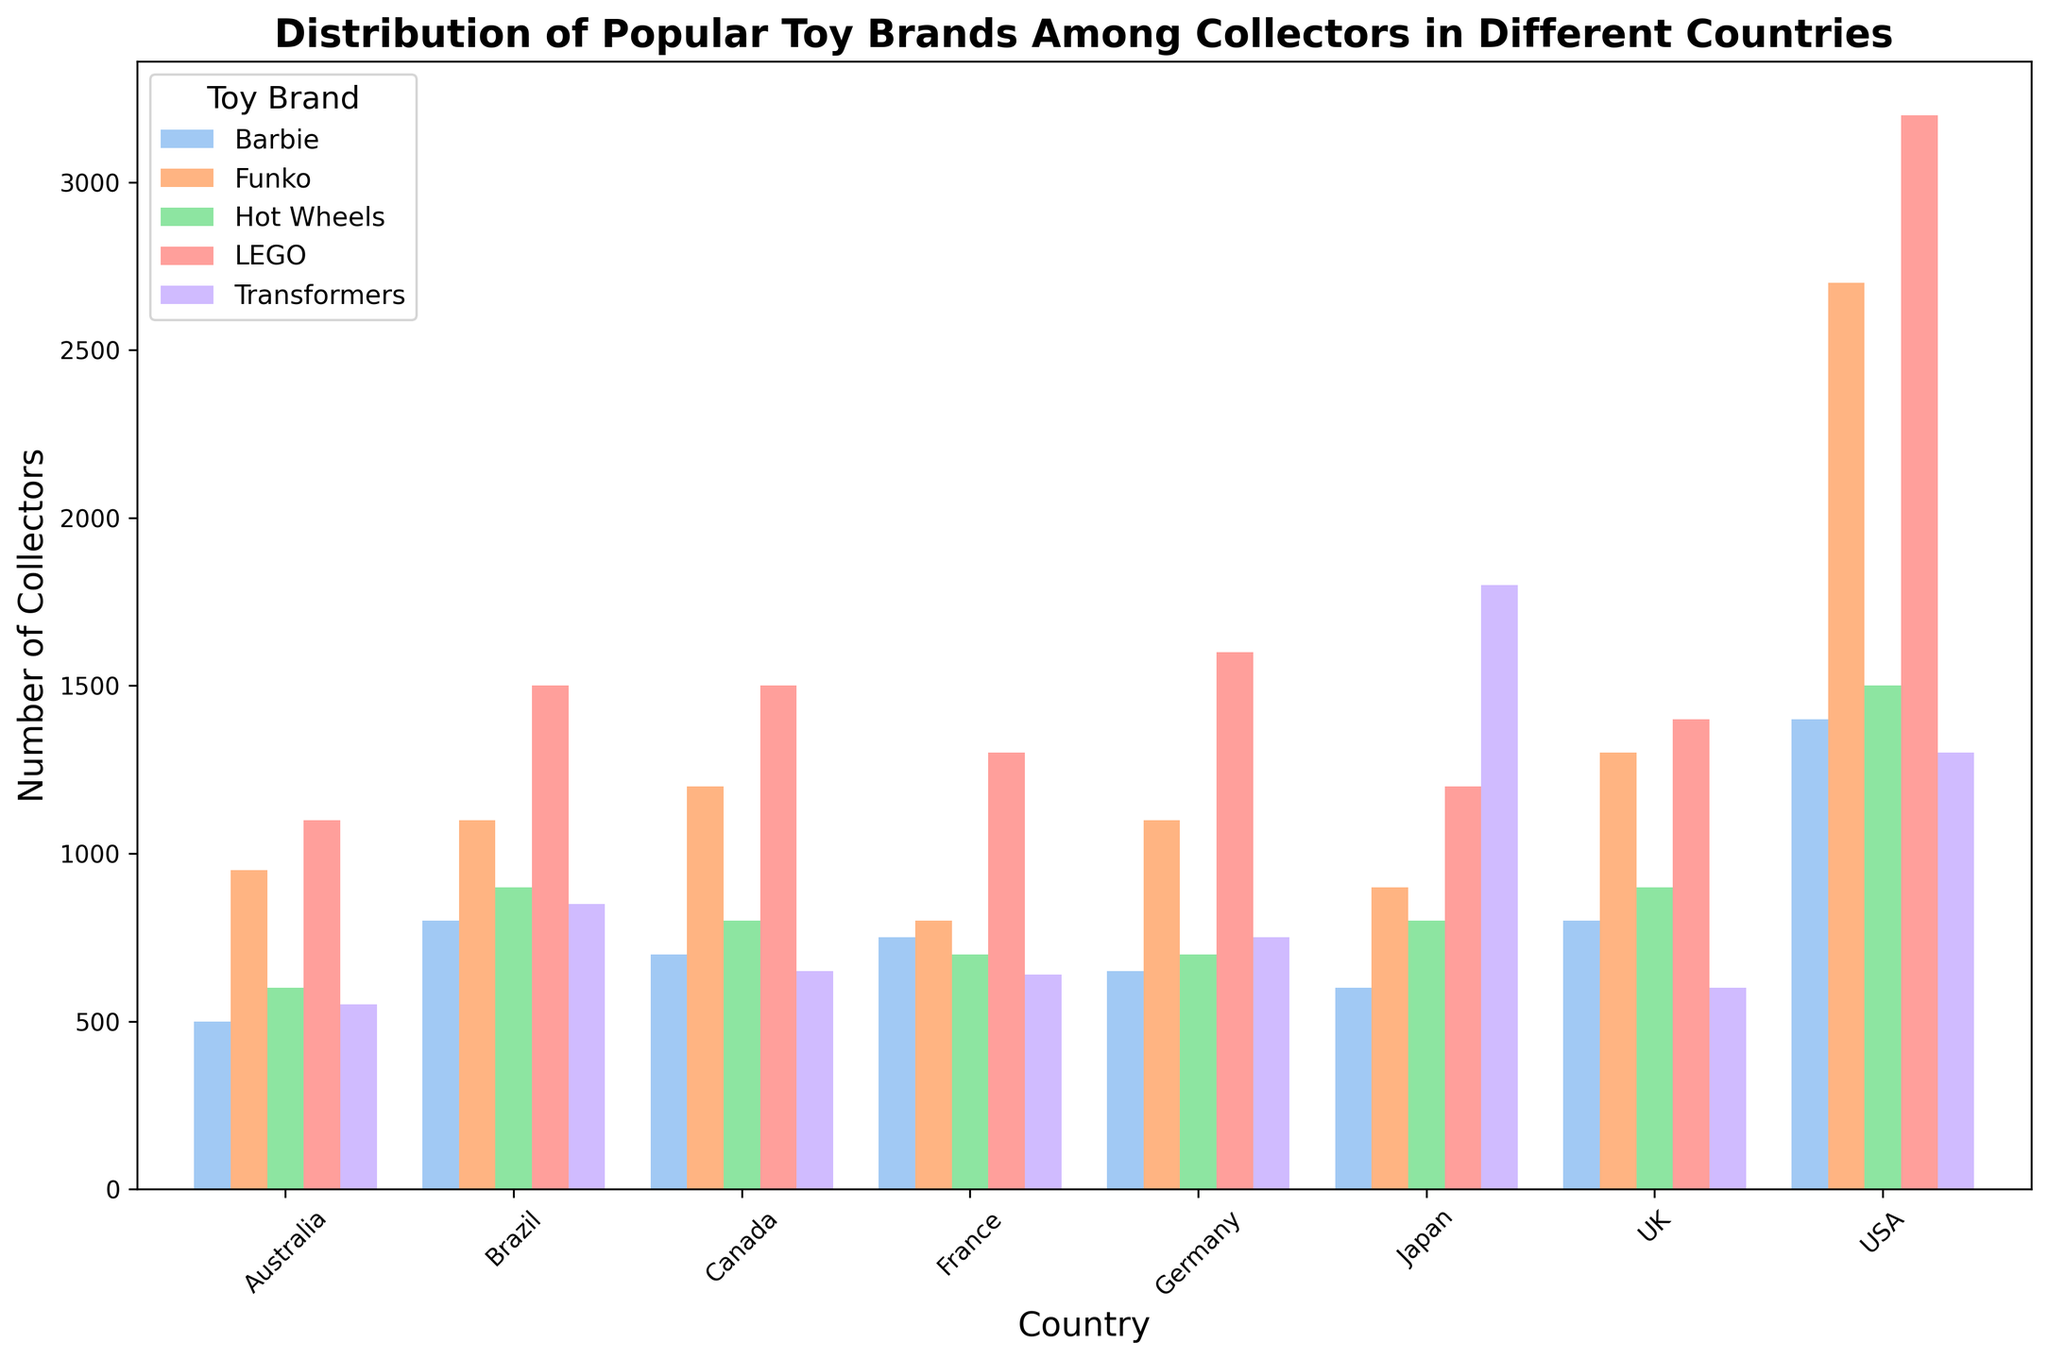Which country has the highest number of LEGO collectors? Observe the bar chart and compare the heights of the bars for LEGO in each country. USA has the tallest bar for LEGO, indicating the highest number of collectors.
Answer: USA Which toy brand has the most collectors in Japan? Look at the heights of the bars corresponding to each toy brand in Japan. The bar for Transformers is the highest.
Answer: Transformers Which country has more Barbie collectors: Germany or France? Compare the height of the bars for Barbie in Germany and France. The bar for Barbie in France is slightly taller than that in Germany.
Answer: France What is the combined number of Hot Wheels and Funko collectors in Canada? Find the heights of the bars for Hot Wheels and Funko in Canada and add them. Hot Wheels: 800, Funko: 1200. Combined: 800 + 1200 = 2000.
Answer: 2000 Across all countries, which toy brand has the most collectors? Compare the sums of the heights of the bars for each toy brand across all countries. LEGO has the tallest bars in most countries.
Answer: LEGO Which country has the smallest difference in the number of collectors between LEGO and Transformers? Calculate the difference between the heights of the bars for LEGO and Transformers in each country. Japan has the smallest difference (1200 LEGO - 1800 Transformers = 600).
Answer: Japan In the UK, how does the number of Barbie collectors compare to the number of Hot Wheels collectors? Observe the heights of the bars for Barbie and Hot Wheels in the UK. The Hot Wheels bar is taller than the Barbie bar.
Answer: Fewer Barbie collectors Which two toy brands have the closest number of collectors in Brazil? Compare the heights of the bars for each toy brand in Brazil. Barbie and Hot Wheels bars are of equal height (900 each).
Answer: Barbie and Hot Wheels What is the total number of transformers collectors in the USA and Brazil combined? Sum the heights of the bars for Transformers in the USA and Brazil. USA: 1300, Brazil: 850. Total: 1300 + 850 = 2150.
Answer: 2150 Which toy brand has the least number of collectors in Australia? Identify the shortest bar for Australia. The bar for Barbie is the shortest among all toy brands.
Answer: Barbie 